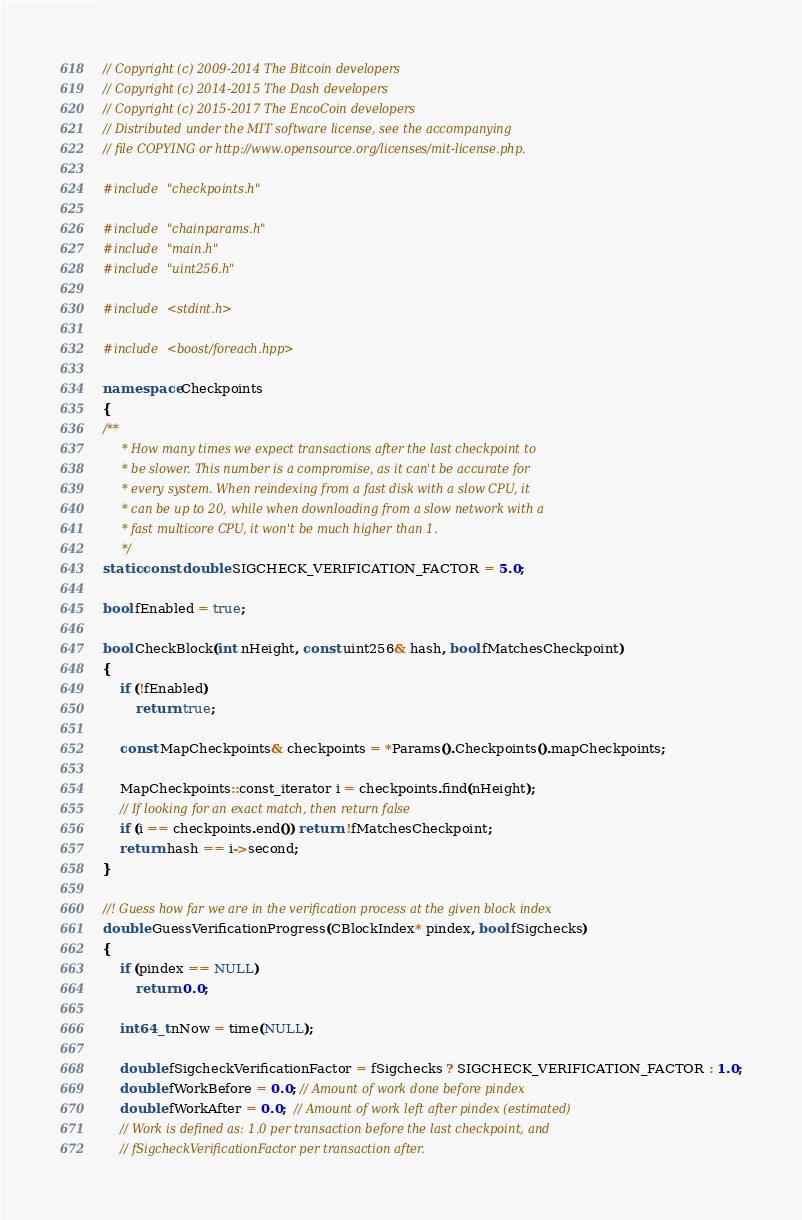Convert code to text. <code><loc_0><loc_0><loc_500><loc_500><_C++_>// Copyright (c) 2009-2014 The Bitcoin developers
// Copyright (c) 2014-2015 The Dash developers
// Copyright (c) 2015-2017 The EncoCoin developers
// Distributed under the MIT software license, see the accompanying
// file COPYING or http://www.opensource.org/licenses/mit-license.php.

#include "checkpoints.h"

#include "chainparams.h"
#include "main.h"
#include "uint256.h"

#include <stdint.h>

#include <boost/foreach.hpp>

namespace Checkpoints
{
/**
     * How many times we expect transactions after the last checkpoint to
     * be slower. This number is a compromise, as it can't be accurate for
     * every system. When reindexing from a fast disk with a slow CPU, it
     * can be up to 20, while when downloading from a slow network with a
     * fast multicore CPU, it won't be much higher than 1.
     */
static const double SIGCHECK_VERIFICATION_FACTOR = 5.0;

bool fEnabled = true;

bool CheckBlock(int nHeight, const uint256& hash, bool fMatchesCheckpoint)
{
    if (!fEnabled)
        return true;

    const MapCheckpoints& checkpoints = *Params().Checkpoints().mapCheckpoints;

    MapCheckpoints::const_iterator i = checkpoints.find(nHeight);
    // If looking for an exact match, then return false
    if (i == checkpoints.end()) return !fMatchesCheckpoint;
    return hash == i->second;
}

//! Guess how far we are in the verification process at the given block index
double GuessVerificationProgress(CBlockIndex* pindex, bool fSigchecks)
{
    if (pindex == NULL)
        return 0.0;

    int64_t nNow = time(NULL);

    double fSigcheckVerificationFactor = fSigchecks ? SIGCHECK_VERIFICATION_FACTOR : 1.0;
    double fWorkBefore = 0.0; // Amount of work done before pindex
    double fWorkAfter = 0.0;  // Amount of work left after pindex (estimated)
    // Work is defined as: 1.0 per transaction before the last checkpoint, and
    // fSigcheckVerificationFactor per transaction after.
</code> 